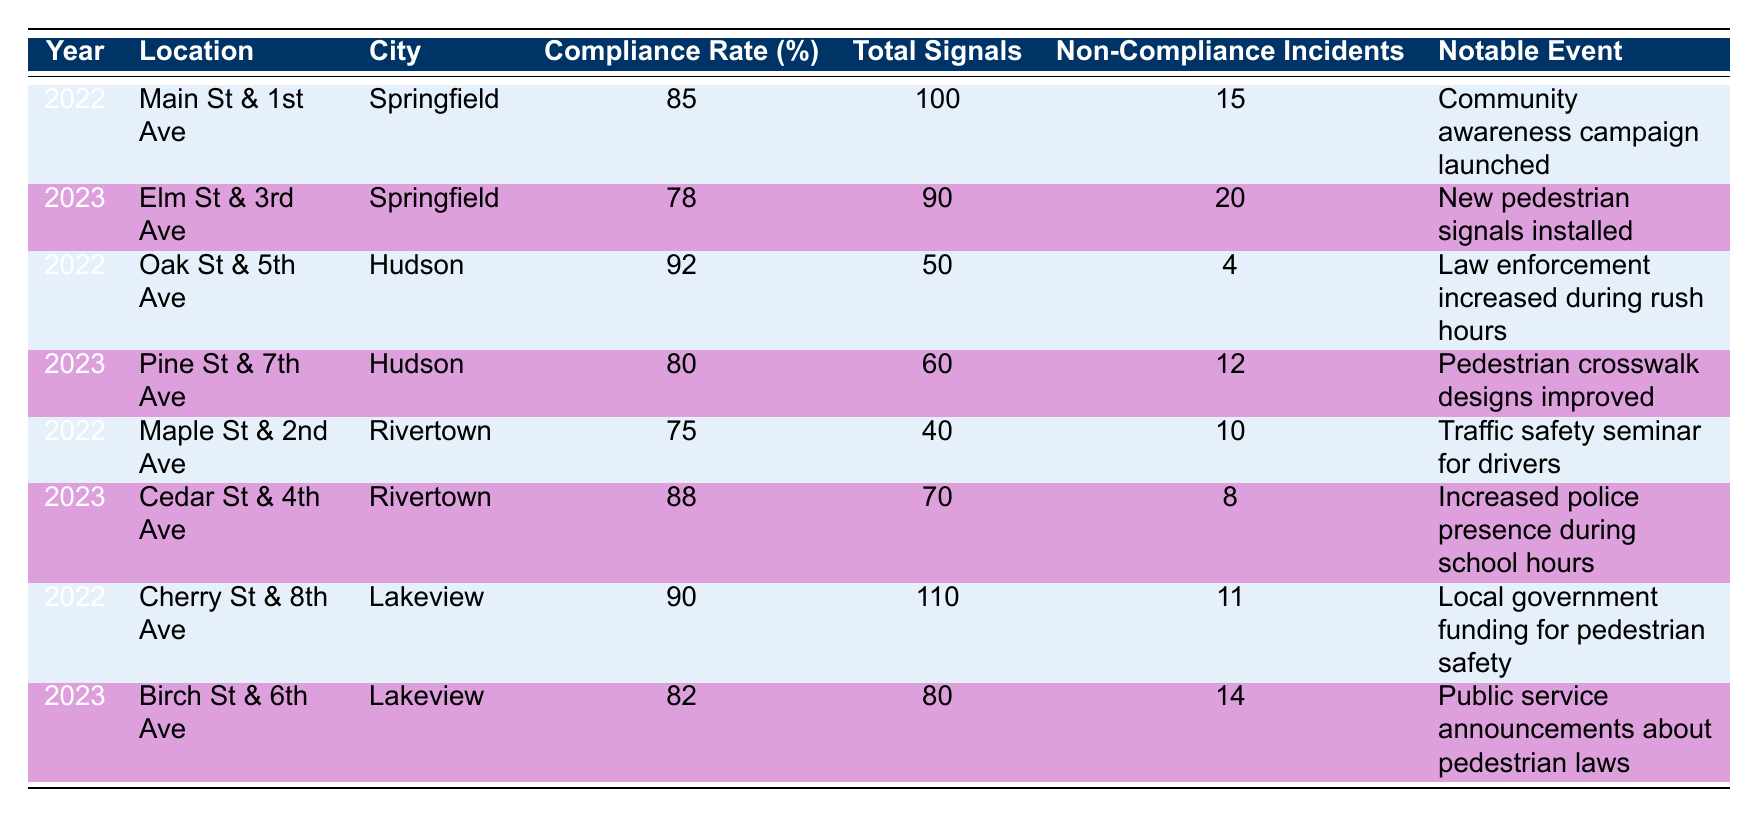What is the compliance rate at Main St & 1st Ave in 2022? The compliance rate for Main St & 1st Ave in 2022 is listed directly in the table as 85%.
Answer: 85% How many non-compliance incidents were reported at Elm St & 3rd Ave in 2023? The table shows that there were 20 non-compliance incidents reported at Elm St & 3rd Ave in 2023.
Answer: 20 Which location had the highest compliance rate in 2022? Looking at the compliance rates for 2022, Oak St & 5th Ave had the highest rate with 92%.
Answer: Oak St & 5th Ave What is the total number of signals at Cedar St & 4th Ave in 2023? The table indicates that Cedar St & 4th Ave had a total of 70 signals in 2023.
Answer: 70 Is the compliance rate at Birch St & 6th Ave higher than 80%? The compliance rate at Birch St & 6th Ave is stated to be 82%, which is higher than 80%.
Answer: Yes What is the difference in compliance rates between Maple St & 2nd Ave in 2022 and Cedar St & 4th Ave in 2023? The compliance rate for Maple St & 2nd Ave in 2022 is 75%, and for Cedar St & 4th Ave in 2023 it is 88%. The difference is 88 - 75 = 13%.
Answer: 13% How many total non-compliance incidents were recorded across all locations in 2023? Adding the non-compliance incidents for 2023: 20 (Elm St & 3rd Ave) + 12 (Pine St & 7th Ave) + 8 (Cedar St & 4th Ave) + 14 (Birch St & 6th Ave) gives a total of 54 incidents.
Answer: 54 Were there any notable events associated with the locations in 2022 that could indicate efforts to improve pedestrian safety? Yes, significant events like a community awareness campaign, increased law enforcement, a traffic safety seminar, and local government funding were all mentioned as notable events in 2022.
Answer: Yes Which city's location had both the highest compliance rate in 2023 and the most notable event aimed at enhancing pedestrian safety? Cedar St & 4th Ave in Rivertown had the highest compliance rate of 88% in 2023 due to increased police presence during school hours.
Answer: Cedar St & 4th Ave in Rivertown 